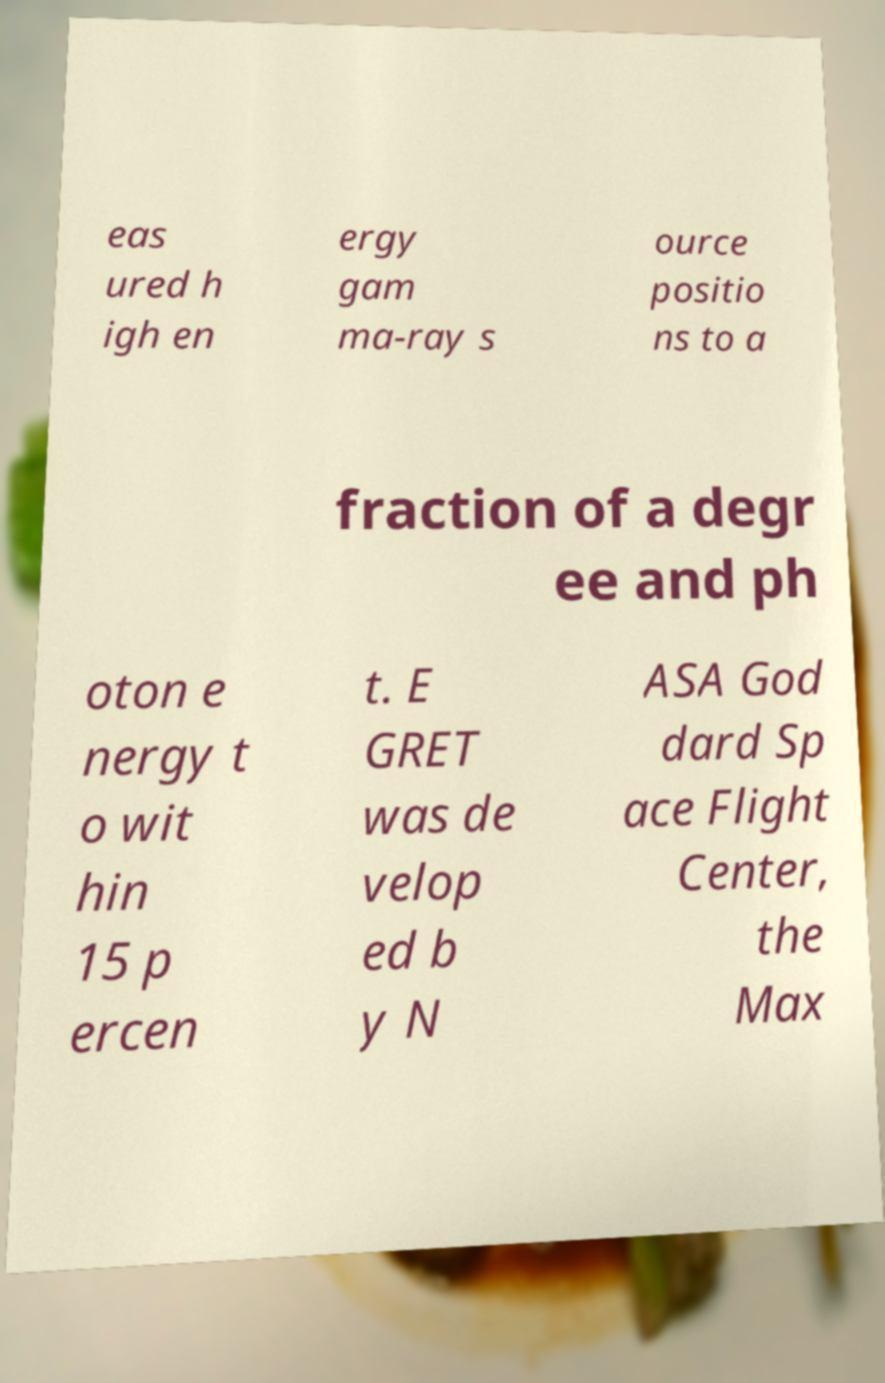Please identify and transcribe the text found in this image. eas ured h igh en ergy gam ma-ray s ource positio ns to a fraction of a degr ee and ph oton e nergy t o wit hin 15 p ercen t. E GRET was de velop ed b y N ASA God dard Sp ace Flight Center, the Max 